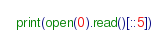Convert code to text. <code><loc_0><loc_0><loc_500><loc_500><_Python_>print(open(0).read()[::5])</code> 